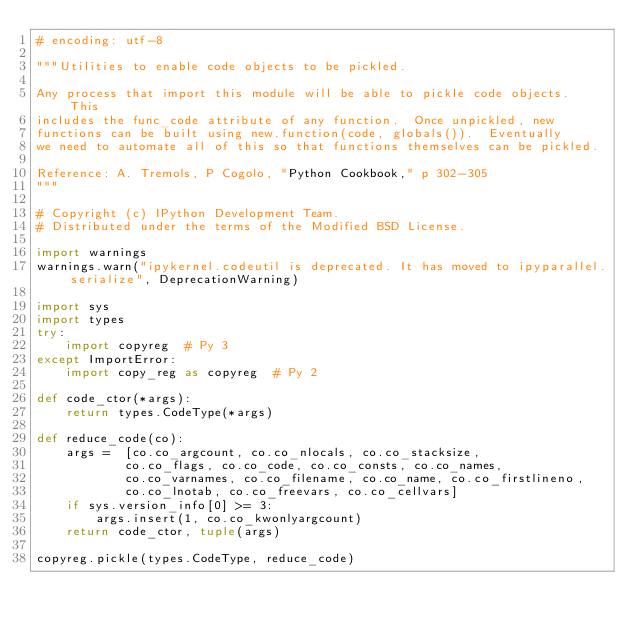Convert code to text. <code><loc_0><loc_0><loc_500><loc_500><_Python_># encoding: utf-8

"""Utilities to enable code objects to be pickled.

Any process that import this module will be able to pickle code objects.  This
includes the func_code attribute of any function.  Once unpickled, new
functions can be built using new.function(code, globals()).  Eventually
we need to automate all of this so that functions themselves can be pickled.

Reference: A. Tremols, P Cogolo, "Python Cookbook," p 302-305
"""

# Copyright (c) IPython Development Team.
# Distributed under the terms of the Modified BSD License.

import warnings
warnings.warn("ipykernel.codeutil is deprecated. It has moved to ipyparallel.serialize", DeprecationWarning)

import sys
import types
try:
    import copyreg  # Py 3
except ImportError:
    import copy_reg as copyreg  # Py 2

def code_ctor(*args):
    return types.CodeType(*args)

def reduce_code(co):
    args =  [co.co_argcount, co.co_nlocals, co.co_stacksize,
            co.co_flags, co.co_code, co.co_consts, co.co_names,
            co.co_varnames, co.co_filename, co.co_name, co.co_firstlineno,
            co.co_lnotab, co.co_freevars, co.co_cellvars]
    if sys.version_info[0] >= 3:
        args.insert(1, co.co_kwonlyargcount)
    return code_ctor, tuple(args)

copyreg.pickle(types.CodeType, reduce_code)</code> 